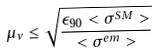Convert formula to latex. <formula><loc_0><loc_0><loc_500><loc_500>\mu _ { \nu } \leq \sqrt { \frac { \epsilon _ { 9 0 } < \sigma ^ { S M } > } { < \sigma ^ { e m } > } }</formula> 